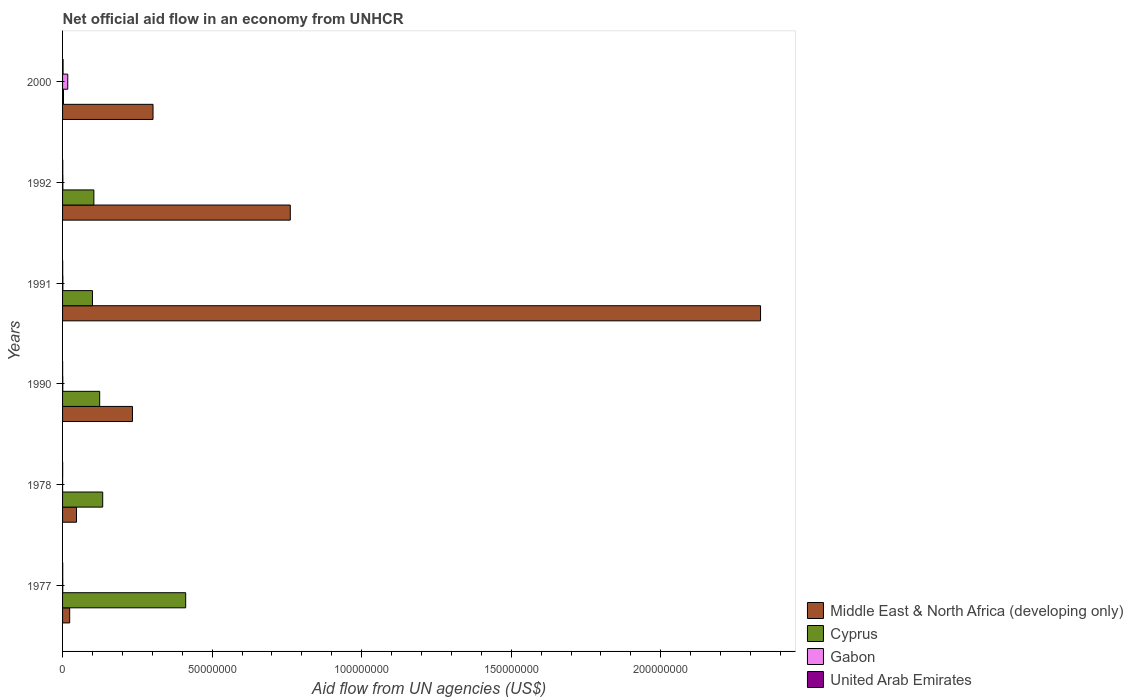How many different coloured bars are there?
Your answer should be very brief. 4. How many groups of bars are there?
Offer a very short reply. 6. Are the number of bars on each tick of the Y-axis equal?
Your answer should be very brief. Yes. How many bars are there on the 6th tick from the top?
Offer a very short reply. 4. How many bars are there on the 2nd tick from the bottom?
Your answer should be compact. 4. In how many cases, is the number of bars for a given year not equal to the number of legend labels?
Give a very brief answer. 0. Across all years, what is the maximum net official aid flow in Middle East & North Africa (developing only)?
Your response must be concise. 2.33e+08. In which year was the net official aid flow in Cyprus maximum?
Ensure brevity in your answer.  1977. In which year was the net official aid flow in Middle East & North Africa (developing only) minimum?
Ensure brevity in your answer.  1977. What is the total net official aid flow in Cyprus in the graph?
Your answer should be very brief. 8.78e+07. What is the difference between the net official aid flow in Cyprus in 1977 and that in 1992?
Give a very brief answer. 3.07e+07. What is the difference between the net official aid flow in United Arab Emirates in 1990 and the net official aid flow in Cyprus in 1978?
Your response must be concise. -1.34e+07. What is the average net official aid flow in Cyprus per year?
Your answer should be very brief. 1.46e+07. In the year 1990, what is the difference between the net official aid flow in Cyprus and net official aid flow in Gabon?
Make the answer very short. 1.23e+07. Is the difference between the net official aid flow in Cyprus in 1991 and 2000 greater than the difference between the net official aid flow in Gabon in 1991 and 2000?
Provide a succinct answer. Yes. What is the difference between the highest and the second highest net official aid flow in Gabon?
Offer a very short reply. 1.64e+06. What is the difference between the highest and the lowest net official aid flow in Gabon?
Ensure brevity in your answer.  1.73e+06. Is it the case that in every year, the sum of the net official aid flow in Middle East & North Africa (developing only) and net official aid flow in Cyprus is greater than the sum of net official aid flow in Gabon and net official aid flow in United Arab Emirates?
Ensure brevity in your answer.  Yes. What does the 3rd bar from the top in 1992 represents?
Your answer should be compact. Cyprus. What does the 4th bar from the bottom in 1990 represents?
Ensure brevity in your answer.  United Arab Emirates. Is it the case that in every year, the sum of the net official aid flow in Cyprus and net official aid flow in United Arab Emirates is greater than the net official aid flow in Middle East & North Africa (developing only)?
Give a very brief answer. No. How many bars are there?
Provide a short and direct response. 24. Are all the bars in the graph horizontal?
Provide a short and direct response. Yes. How many years are there in the graph?
Offer a terse response. 6. What is the difference between two consecutive major ticks on the X-axis?
Give a very brief answer. 5.00e+07. Does the graph contain any zero values?
Offer a very short reply. No. How many legend labels are there?
Your response must be concise. 4. How are the legend labels stacked?
Make the answer very short. Vertical. What is the title of the graph?
Your answer should be compact. Net official aid flow in an economy from UNHCR. Does "Philippines" appear as one of the legend labels in the graph?
Give a very brief answer. No. What is the label or title of the X-axis?
Provide a short and direct response. Aid flow from UN agencies (US$). What is the Aid flow from UN agencies (US$) of Middle East & North Africa (developing only) in 1977?
Make the answer very short. 2.38e+06. What is the Aid flow from UN agencies (US$) of Cyprus in 1977?
Make the answer very short. 4.12e+07. What is the Aid flow from UN agencies (US$) of Gabon in 1977?
Your answer should be compact. 6.00e+04. What is the Aid flow from UN agencies (US$) of United Arab Emirates in 1977?
Provide a short and direct response. 5.00e+04. What is the Aid flow from UN agencies (US$) of Middle East & North Africa (developing only) in 1978?
Your answer should be compact. 4.66e+06. What is the Aid flow from UN agencies (US$) of Cyprus in 1978?
Provide a short and direct response. 1.34e+07. What is the Aid flow from UN agencies (US$) of Gabon in 1978?
Ensure brevity in your answer.  10000. What is the Aid flow from UN agencies (US$) in Middle East & North Africa (developing only) in 1990?
Your answer should be compact. 2.34e+07. What is the Aid flow from UN agencies (US$) of Cyprus in 1990?
Offer a terse response. 1.24e+07. What is the Aid flow from UN agencies (US$) in Gabon in 1990?
Your answer should be very brief. 7.00e+04. What is the Aid flow from UN agencies (US$) of United Arab Emirates in 1990?
Your answer should be very brief. 2.00e+04. What is the Aid flow from UN agencies (US$) in Middle East & North Africa (developing only) in 1991?
Your response must be concise. 2.33e+08. What is the Aid flow from UN agencies (US$) of Cyprus in 1991?
Offer a very short reply. 1.00e+07. What is the Aid flow from UN agencies (US$) in Gabon in 1991?
Your response must be concise. 1.00e+05. What is the Aid flow from UN agencies (US$) in Middle East & North Africa (developing only) in 1992?
Your answer should be compact. 7.61e+07. What is the Aid flow from UN agencies (US$) of Cyprus in 1992?
Give a very brief answer. 1.05e+07. What is the Aid flow from UN agencies (US$) of Gabon in 1992?
Your response must be concise. 1.00e+05. What is the Aid flow from UN agencies (US$) in Middle East & North Africa (developing only) in 2000?
Keep it short and to the point. 3.02e+07. What is the Aid flow from UN agencies (US$) of Cyprus in 2000?
Offer a terse response. 3.10e+05. What is the Aid flow from UN agencies (US$) in Gabon in 2000?
Your answer should be very brief. 1.74e+06. Across all years, what is the maximum Aid flow from UN agencies (US$) in Middle East & North Africa (developing only)?
Your answer should be compact. 2.33e+08. Across all years, what is the maximum Aid flow from UN agencies (US$) in Cyprus?
Give a very brief answer. 4.12e+07. Across all years, what is the maximum Aid flow from UN agencies (US$) in Gabon?
Ensure brevity in your answer.  1.74e+06. Across all years, what is the minimum Aid flow from UN agencies (US$) of Middle East & North Africa (developing only)?
Give a very brief answer. 2.38e+06. Across all years, what is the minimum Aid flow from UN agencies (US$) in United Arab Emirates?
Provide a short and direct response. 2.00e+04. What is the total Aid flow from UN agencies (US$) of Middle East & North Africa (developing only) in the graph?
Your response must be concise. 3.70e+08. What is the total Aid flow from UN agencies (US$) of Cyprus in the graph?
Make the answer very short. 8.78e+07. What is the total Aid flow from UN agencies (US$) in Gabon in the graph?
Your answer should be very brief. 2.08e+06. What is the total Aid flow from UN agencies (US$) in United Arab Emirates in the graph?
Your answer should be very brief. 3.70e+05. What is the difference between the Aid flow from UN agencies (US$) of Middle East & North Africa (developing only) in 1977 and that in 1978?
Provide a short and direct response. -2.28e+06. What is the difference between the Aid flow from UN agencies (US$) in Cyprus in 1977 and that in 1978?
Provide a short and direct response. 2.78e+07. What is the difference between the Aid flow from UN agencies (US$) in Gabon in 1977 and that in 1978?
Offer a terse response. 5.00e+04. What is the difference between the Aid flow from UN agencies (US$) in Middle East & North Africa (developing only) in 1977 and that in 1990?
Offer a terse response. -2.10e+07. What is the difference between the Aid flow from UN agencies (US$) of Cyprus in 1977 and that in 1990?
Keep it short and to the point. 2.88e+07. What is the difference between the Aid flow from UN agencies (US$) in Middle East & North Africa (developing only) in 1977 and that in 1991?
Offer a terse response. -2.31e+08. What is the difference between the Aid flow from UN agencies (US$) in Cyprus in 1977 and that in 1991?
Ensure brevity in your answer.  3.12e+07. What is the difference between the Aid flow from UN agencies (US$) in United Arab Emirates in 1977 and that in 1991?
Give a very brief answer. 10000. What is the difference between the Aid flow from UN agencies (US$) in Middle East & North Africa (developing only) in 1977 and that in 1992?
Your response must be concise. -7.38e+07. What is the difference between the Aid flow from UN agencies (US$) in Cyprus in 1977 and that in 1992?
Ensure brevity in your answer.  3.07e+07. What is the difference between the Aid flow from UN agencies (US$) in Middle East & North Africa (developing only) in 1977 and that in 2000?
Provide a short and direct response. -2.79e+07. What is the difference between the Aid flow from UN agencies (US$) in Cyprus in 1977 and that in 2000?
Give a very brief answer. 4.09e+07. What is the difference between the Aid flow from UN agencies (US$) of Gabon in 1977 and that in 2000?
Provide a short and direct response. -1.68e+06. What is the difference between the Aid flow from UN agencies (US$) of Middle East & North Africa (developing only) in 1978 and that in 1990?
Ensure brevity in your answer.  -1.87e+07. What is the difference between the Aid flow from UN agencies (US$) of Cyprus in 1978 and that in 1990?
Your answer should be very brief. 1.01e+06. What is the difference between the Aid flow from UN agencies (US$) in Middle East & North Africa (developing only) in 1978 and that in 1991?
Ensure brevity in your answer.  -2.29e+08. What is the difference between the Aid flow from UN agencies (US$) in Cyprus in 1978 and that in 1991?
Ensure brevity in your answer.  3.42e+06. What is the difference between the Aid flow from UN agencies (US$) of Middle East & North Africa (developing only) in 1978 and that in 1992?
Ensure brevity in your answer.  -7.15e+07. What is the difference between the Aid flow from UN agencies (US$) of Cyprus in 1978 and that in 1992?
Provide a short and direct response. 2.95e+06. What is the difference between the Aid flow from UN agencies (US$) of Gabon in 1978 and that in 1992?
Your answer should be very brief. -9.00e+04. What is the difference between the Aid flow from UN agencies (US$) in United Arab Emirates in 1978 and that in 1992?
Keep it short and to the point. -3.00e+04. What is the difference between the Aid flow from UN agencies (US$) in Middle East & North Africa (developing only) in 1978 and that in 2000?
Keep it short and to the point. -2.56e+07. What is the difference between the Aid flow from UN agencies (US$) in Cyprus in 1978 and that in 2000?
Provide a succinct answer. 1.31e+07. What is the difference between the Aid flow from UN agencies (US$) in Gabon in 1978 and that in 2000?
Offer a very short reply. -1.73e+06. What is the difference between the Aid flow from UN agencies (US$) in Middle East & North Africa (developing only) in 1990 and that in 1991?
Your response must be concise. -2.10e+08. What is the difference between the Aid flow from UN agencies (US$) of Cyprus in 1990 and that in 1991?
Your response must be concise. 2.41e+06. What is the difference between the Aid flow from UN agencies (US$) in Gabon in 1990 and that in 1991?
Make the answer very short. -3.00e+04. What is the difference between the Aid flow from UN agencies (US$) in United Arab Emirates in 1990 and that in 1991?
Provide a short and direct response. -2.00e+04. What is the difference between the Aid flow from UN agencies (US$) in Middle East & North Africa (developing only) in 1990 and that in 1992?
Provide a succinct answer. -5.28e+07. What is the difference between the Aid flow from UN agencies (US$) in Cyprus in 1990 and that in 1992?
Ensure brevity in your answer.  1.94e+06. What is the difference between the Aid flow from UN agencies (US$) in United Arab Emirates in 1990 and that in 1992?
Ensure brevity in your answer.  -4.00e+04. What is the difference between the Aid flow from UN agencies (US$) in Middle East & North Africa (developing only) in 1990 and that in 2000?
Ensure brevity in your answer.  -6.88e+06. What is the difference between the Aid flow from UN agencies (US$) of Cyprus in 1990 and that in 2000?
Keep it short and to the point. 1.21e+07. What is the difference between the Aid flow from UN agencies (US$) in Gabon in 1990 and that in 2000?
Your response must be concise. -1.67e+06. What is the difference between the Aid flow from UN agencies (US$) of United Arab Emirates in 1990 and that in 2000?
Ensure brevity in your answer.  -1.50e+05. What is the difference between the Aid flow from UN agencies (US$) in Middle East & North Africa (developing only) in 1991 and that in 1992?
Give a very brief answer. 1.57e+08. What is the difference between the Aid flow from UN agencies (US$) of Cyprus in 1991 and that in 1992?
Keep it short and to the point. -4.70e+05. What is the difference between the Aid flow from UN agencies (US$) of United Arab Emirates in 1991 and that in 1992?
Give a very brief answer. -2.00e+04. What is the difference between the Aid flow from UN agencies (US$) of Middle East & North Africa (developing only) in 1991 and that in 2000?
Your answer should be compact. 2.03e+08. What is the difference between the Aid flow from UN agencies (US$) in Cyprus in 1991 and that in 2000?
Your answer should be very brief. 9.69e+06. What is the difference between the Aid flow from UN agencies (US$) in Gabon in 1991 and that in 2000?
Offer a very short reply. -1.64e+06. What is the difference between the Aid flow from UN agencies (US$) in Middle East & North Africa (developing only) in 1992 and that in 2000?
Give a very brief answer. 4.59e+07. What is the difference between the Aid flow from UN agencies (US$) in Cyprus in 1992 and that in 2000?
Keep it short and to the point. 1.02e+07. What is the difference between the Aid flow from UN agencies (US$) in Gabon in 1992 and that in 2000?
Your answer should be very brief. -1.64e+06. What is the difference between the Aid flow from UN agencies (US$) of United Arab Emirates in 1992 and that in 2000?
Your answer should be very brief. -1.10e+05. What is the difference between the Aid flow from UN agencies (US$) in Middle East & North Africa (developing only) in 1977 and the Aid flow from UN agencies (US$) in Cyprus in 1978?
Your answer should be compact. -1.10e+07. What is the difference between the Aid flow from UN agencies (US$) in Middle East & North Africa (developing only) in 1977 and the Aid flow from UN agencies (US$) in Gabon in 1978?
Keep it short and to the point. 2.37e+06. What is the difference between the Aid flow from UN agencies (US$) of Middle East & North Africa (developing only) in 1977 and the Aid flow from UN agencies (US$) of United Arab Emirates in 1978?
Make the answer very short. 2.35e+06. What is the difference between the Aid flow from UN agencies (US$) in Cyprus in 1977 and the Aid flow from UN agencies (US$) in Gabon in 1978?
Your answer should be very brief. 4.12e+07. What is the difference between the Aid flow from UN agencies (US$) of Cyprus in 1977 and the Aid flow from UN agencies (US$) of United Arab Emirates in 1978?
Offer a very short reply. 4.11e+07. What is the difference between the Aid flow from UN agencies (US$) of Middle East & North Africa (developing only) in 1977 and the Aid flow from UN agencies (US$) of Cyprus in 1990?
Offer a terse response. -1.00e+07. What is the difference between the Aid flow from UN agencies (US$) in Middle East & North Africa (developing only) in 1977 and the Aid flow from UN agencies (US$) in Gabon in 1990?
Ensure brevity in your answer.  2.31e+06. What is the difference between the Aid flow from UN agencies (US$) in Middle East & North Africa (developing only) in 1977 and the Aid flow from UN agencies (US$) in United Arab Emirates in 1990?
Offer a terse response. 2.36e+06. What is the difference between the Aid flow from UN agencies (US$) in Cyprus in 1977 and the Aid flow from UN agencies (US$) in Gabon in 1990?
Your answer should be compact. 4.11e+07. What is the difference between the Aid flow from UN agencies (US$) in Cyprus in 1977 and the Aid flow from UN agencies (US$) in United Arab Emirates in 1990?
Your answer should be compact. 4.12e+07. What is the difference between the Aid flow from UN agencies (US$) of Gabon in 1977 and the Aid flow from UN agencies (US$) of United Arab Emirates in 1990?
Ensure brevity in your answer.  4.00e+04. What is the difference between the Aid flow from UN agencies (US$) in Middle East & North Africa (developing only) in 1977 and the Aid flow from UN agencies (US$) in Cyprus in 1991?
Offer a very short reply. -7.62e+06. What is the difference between the Aid flow from UN agencies (US$) in Middle East & North Africa (developing only) in 1977 and the Aid flow from UN agencies (US$) in Gabon in 1991?
Your answer should be very brief. 2.28e+06. What is the difference between the Aid flow from UN agencies (US$) in Middle East & North Africa (developing only) in 1977 and the Aid flow from UN agencies (US$) in United Arab Emirates in 1991?
Provide a short and direct response. 2.34e+06. What is the difference between the Aid flow from UN agencies (US$) in Cyprus in 1977 and the Aid flow from UN agencies (US$) in Gabon in 1991?
Keep it short and to the point. 4.11e+07. What is the difference between the Aid flow from UN agencies (US$) in Cyprus in 1977 and the Aid flow from UN agencies (US$) in United Arab Emirates in 1991?
Offer a terse response. 4.11e+07. What is the difference between the Aid flow from UN agencies (US$) of Middle East & North Africa (developing only) in 1977 and the Aid flow from UN agencies (US$) of Cyprus in 1992?
Keep it short and to the point. -8.09e+06. What is the difference between the Aid flow from UN agencies (US$) of Middle East & North Africa (developing only) in 1977 and the Aid flow from UN agencies (US$) of Gabon in 1992?
Ensure brevity in your answer.  2.28e+06. What is the difference between the Aid flow from UN agencies (US$) in Middle East & North Africa (developing only) in 1977 and the Aid flow from UN agencies (US$) in United Arab Emirates in 1992?
Provide a short and direct response. 2.32e+06. What is the difference between the Aid flow from UN agencies (US$) in Cyprus in 1977 and the Aid flow from UN agencies (US$) in Gabon in 1992?
Your answer should be compact. 4.11e+07. What is the difference between the Aid flow from UN agencies (US$) of Cyprus in 1977 and the Aid flow from UN agencies (US$) of United Arab Emirates in 1992?
Offer a terse response. 4.11e+07. What is the difference between the Aid flow from UN agencies (US$) in Middle East & North Africa (developing only) in 1977 and the Aid flow from UN agencies (US$) in Cyprus in 2000?
Make the answer very short. 2.07e+06. What is the difference between the Aid flow from UN agencies (US$) in Middle East & North Africa (developing only) in 1977 and the Aid flow from UN agencies (US$) in Gabon in 2000?
Offer a very short reply. 6.40e+05. What is the difference between the Aid flow from UN agencies (US$) in Middle East & North Africa (developing only) in 1977 and the Aid flow from UN agencies (US$) in United Arab Emirates in 2000?
Your answer should be very brief. 2.21e+06. What is the difference between the Aid flow from UN agencies (US$) of Cyprus in 1977 and the Aid flow from UN agencies (US$) of Gabon in 2000?
Your response must be concise. 3.94e+07. What is the difference between the Aid flow from UN agencies (US$) in Cyprus in 1977 and the Aid flow from UN agencies (US$) in United Arab Emirates in 2000?
Give a very brief answer. 4.10e+07. What is the difference between the Aid flow from UN agencies (US$) of Gabon in 1977 and the Aid flow from UN agencies (US$) of United Arab Emirates in 2000?
Offer a very short reply. -1.10e+05. What is the difference between the Aid flow from UN agencies (US$) in Middle East & North Africa (developing only) in 1978 and the Aid flow from UN agencies (US$) in Cyprus in 1990?
Provide a short and direct response. -7.75e+06. What is the difference between the Aid flow from UN agencies (US$) in Middle East & North Africa (developing only) in 1978 and the Aid flow from UN agencies (US$) in Gabon in 1990?
Offer a very short reply. 4.59e+06. What is the difference between the Aid flow from UN agencies (US$) of Middle East & North Africa (developing only) in 1978 and the Aid flow from UN agencies (US$) of United Arab Emirates in 1990?
Your answer should be compact. 4.64e+06. What is the difference between the Aid flow from UN agencies (US$) in Cyprus in 1978 and the Aid flow from UN agencies (US$) in Gabon in 1990?
Provide a succinct answer. 1.34e+07. What is the difference between the Aid flow from UN agencies (US$) in Cyprus in 1978 and the Aid flow from UN agencies (US$) in United Arab Emirates in 1990?
Provide a succinct answer. 1.34e+07. What is the difference between the Aid flow from UN agencies (US$) of Gabon in 1978 and the Aid flow from UN agencies (US$) of United Arab Emirates in 1990?
Your answer should be compact. -10000. What is the difference between the Aid flow from UN agencies (US$) of Middle East & North Africa (developing only) in 1978 and the Aid flow from UN agencies (US$) of Cyprus in 1991?
Keep it short and to the point. -5.34e+06. What is the difference between the Aid flow from UN agencies (US$) of Middle East & North Africa (developing only) in 1978 and the Aid flow from UN agencies (US$) of Gabon in 1991?
Ensure brevity in your answer.  4.56e+06. What is the difference between the Aid flow from UN agencies (US$) of Middle East & North Africa (developing only) in 1978 and the Aid flow from UN agencies (US$) of United Arab Emirates in 1991?
Provide a succinct answer. 4.62e+06. What is the difference between the Aid flow from UN agencies (US$) in Cyprus in 1978 and the Aid flow from UN agencies (US$) in Gabon in 1991?
Your response must be concise. 1.33e+07. What is the difference between the Aid flow from UN agencies (US$) of Cyprus in 1978 and the Aid flow from UN agencies (US$) of United Arab Emirates in 1991?
Offer a terse response. 1.34e+07. What is the difference between the Aid flow from UN agencies (US$) of Gabon in 1978 and the Aid flow from UN agencies (US$) of United Arab Emirates in 1991?
Keep it short and to the point. -3.00e+04. What is the difference between the Aid flow from UN agencies (US$) in Middle East & North Africa (developing only) in 1978 and the Aid flow from UN agencies (US$) in Cyprus in 1992?
Make the answer very short. -5.81e+06. What is the difference between the Aid flow from UN agencies (US$) in Middle East & North Africa (developing only) in 1978 and the Aid flow from UN agencies (US$) in Gabon in 1992?
Your answer should be very brief. 4.56e+06. What is the difference between the Aid flow from UN agencies (US$) of Middle East & North Africa (developing only) in 1978 and the Aid flow from UN agencies (US$) of United Arab Emirates in 1992?
Keep it short and to the point. 4.60e+06. What is the difference between the Aid flow from UN agencies (US$) in Cyprus in 1978 and the Aid flow from UN agencies (US$) in Gabon in 1992?
Your response must be concise. 1.33e+07. What is the difference between the Aid flow from UN agencies (US$) in Cyprus in 1978 and the Aid flow from UN agencies (US$) in United Arab Emirates in 1992?
Give a very brief answer. 1.34e+07. What is the difference between the Aid flow from UN agencies (US$) of Middle East & North Africa (developing only) in 1978 and the Aid flow from UN agencies (US$) of Cyprus in 2000?
Ensure brevity in your answer.  4.35e+06. What is the difference between the Aid flow from UN agencies (US$) of Middle East & North Africa (developing only) in 1978 and the Aid flow from UN agencies (US$) of Gabon in 2000?
Offer a very short reply. 2.92e+06. What is the difference between the Aid flow from UN agencies (US$) in Middle East & North Africa (developing only) in 1978 and the Aid flow from UN agencies (US$) in United Arab Emirates in 2000?
Give a very brief answer. 4.49e+06. What is the difference between the Aid flow from UN agencies (US$) in Cyprus in 1978 and the Aid flow from UN agencies (US$) in Gabon in 2000?
Give a very brief answer. 1.17e+07. What is the difference between the Aid flow from UN agencies (US$) in Cyprus in 1978 and the Aid flow from UN agencies (US$) in United Arab Emirates in 2000?
Make the answer very short. 1.32e+07. What is the difference between the Aid flow from UN agencies (US$) in Gabon in 1978 and the Aid flow from UN agencies (US$) in United Arab Emirates in 2000?
Your response must be concise. -1.60e+05. What is the difference between the Aid flow from UN agencies (US$) of Middle East & North Africa (developing only) in 1990 and the Aid flow from UN agencies (US$) of Cyprus in 1991?
Your response must be concise. 1.34e+07. What is the difference between the Aid flow from UN agencies (US$) in Middle East & North Africa (developing only) in 1990 and the Aid flow from UN agencies (US$) in Gabon in 1991?
Give a very brief answer. 2.33e+07. What is the difference between the Aid flow from UN agencies (US$) in Middle East & North Africa (developing only) in 1990 and the Aid flow from UN agencies (US$) in United Arab Emirates in 1991?
Make the answer very short. 2.33e+07. What is the difference between the Aid flow from UN agencies (US$) in Cyprus in 1990 and the Aid flow from UN agencies (US$) in Gabon in 1991?
Offer a terse response. 1.23e+07. What is the difference between the Aid flow from UN agencies (US$) in Cyprus in 1990 and the Aid flow from UN agencies (US$) in United Arab Emirates in 1991?
Your answer should be compact. 1.24e+07. What is the difference between the Aid flow from UN agencies (US$) in Middle East & North Africa (developing only) in 1990 and the Aid flow from UN agencies (US$) in Cyprus in 1992?
Keep it short and to the point. 1.29e+07. What is the difference between the Aid flow from UN agencies (US$) in Middle East & North Africa (developing only) in 1990 and the Aid flow from UN agencies (US$) in Gabon in 1992?
Offer a very short reply. 2.33e+07. What is the difference between the Aid flow from UN agencies (US$) of Middle East & North Africa (developing only) in 1990 and the Aid flow from UN agencies (US$) of United Arab Emirates in 1992?
Your answer should be compact. 2.33e+07. What is the difference between the Aid flow from UN agencies (US$) of Cyprus in 1990 and the Aid flow from UN agencies (US$) of Gabon in 1992?
Give a very brief answer. 1.23e+07. What is the difference between the Aid flow from UN agencies (US$) of Cyprus in 1990 and the Aid flow from UN agencies (US$) of United Arab Emirates in 1992?
Your answer should be compact. 1.24e+07. What is the difference between the Aid flow from UN agencies (US$) of Middle East & North Africa (developing only) in 1990 and the Aid flow from UN agencies (US$) of Cyprus in 2000?
Offer a very short reply. 2.31e+07. What is the difference between the Aid flow from UN agencies (US$) of Middle East & North Africa (developing only) in 1990 and the Aid flow from UN agencies (US$) of Gabon in 2000?
Provide a succinct answer. 2.16e+07. What is the difference between the Aid flow from UN agencies (US$) in Middle East & North Africa (developing only) in 1990 and the Aid flow from UN agencies (US$) in United Arab Emirates in 2000?
Your answer should be very brief. 2.32e+07. What is the difference between the Aid flow from UN agencies (US$) in Cyprus in 1990 and the Aid flow from UN agencies (US$) in Gabon in 2000?
Provide a short and direct response. 1.07e+07. What is the difference between the Aid flow from UN agencies (US$) of Cyprus in 1990 and the Aid flow from UN agencies (US$) of United Arab Emirates in 2000?
Provide a short and direct response. 1.22e+07. What is the difference between the Aid flow from UN agencies (US$) of Middle East & North Africa (developing only) in 1991 and the Aid flow from UN agencies (US$) of Cyprus in 1992?
Make the answer very short. 2.23e+08. What is the difference between the Aid flow from UN agencies (US$) in Middle East & North Africa (developing only) in 1991 and the Aid flow from UN agencies (US$) in Gabon in 1992?
Provide a succinct answer. 2.33e+08. What is the difference between the Aid flow from UN agencies (US$) in Middle East & North Africa (developing only) in 1991 and the Aid flow from UN agencies (US$) in United Arab Emirates in 1992?
Give a very brief answer. 2.33e+08. What is the difference between the Aid flow from UN agencies (US$) of Cyprus in 1991 and the Aid flow from UN agencies (US$) of Gabon in 1992?
Provide a short and direct response. 9.90e+06. What is the difference between the Aid flow from UN agencies (US$) of Cyprus in 1991 and the Aid flow from UN agencies (US$) of United Arab Emirates in 1992?
Give a very brief answer. 9.94e+06. What is the difference between the Aid flow from UN agencies (US$) of Gabon in 1991 and the Aid flow from UN agencies (US$) of United Arab Emirates in 1992?
Your response must be concise. 4.00e+04. What is the difference between the Aid flow from UN agencies (US$) in Middle East & North Africa (developing only) in 1991 and the Aid flow from UN agencies (US$) in Cyprus in 2000?
Keep it short and to the point. 2.33e+08. What is the difference between the Aid flow from UN agencies (US$) in Middle East & North Africa (developing only) in 1991 and the Aid flow from UN agencies (US$) in Gabon in 2000?
Your answer should be very brief. 2.32e+08. What is the difference between the Aid flow from UN agencies (US$) in Middle East & North Africa (developing only) in 1991 and the Aid flow from UN agencies (US$) in United Arab Emirates in 2000?
Offer a terse response. 2.33e+08. What is the difference between the Aid flow from UN agencies (US$) in Cyprus in 1991 and the Aid flow from UN agencies (US$) in Gabon in 2000?
Provide a succinct answer. 8.26e+06. What is the difference between the Aid flow from UN agencies (US$) in Cyprus in 1991 and the Aid flow from UN agencies (US$) in United Arab Emirates in 2000?
Your response must be concise. 9.83e+06. What is the difference between the Aid flow from UN agencies (US$) of Gabon in 1991 and the Aid flow from UN agencies (US$) of United Arab Emirates in 2000?
Keep it short and to the point. -7.00e+04. What is the difference between the Aid flow from UN agencies (US$) of Middle East & North Africa (developing only) in 1992 and the Aid flow from UN agencies (US$) of Cyprus in 2000?
Provide a succinct answer. 7.58e+07. What is the difference between the Aid flow from UN agencies (US$) in Middle East & North Africa (developing only) in 1992 and the Aid flow from UN agencies (US$) in Gabon in 2000?
Keep it short and to the point. 7.44e+07. What is the difference between the Aid flow from UN agencies (US$) of Middle East & North Africa (developing only) in 1992 and the Aid flow from UN agencies (US$) of United Arab Emirates in 2000?
Offer a very short reply. 7.60e+07. What is the difference between the Aid flow from UN agencies (US$) in Cyprus in 1992 and the Aid flow from UN agencies (US$) in Gabon in 2000?
Ensure brevity in your answer.  8.73e+06. What is the difference between the Aid flow from UN agencies (US$) of Cyprus in 1992 and the Aid flow from UN agencies (US$) of United Arab Emirates in 2000?
Ensure brevity in your answer.  1.03e+07. What is the average Aid flow from UN agencies (US$) of Middle East & North Africa (developing only) per year?
Make the answer very short. 6.17e+07. What is the average Aid flow from UN agencies (US$) of Cyprus per year?
Provide a succinct answer. 1.46e+07. What is the average Aid flow from UN agencies (US$) in Gabon per year?
Your answer should be compact. 3.47e+05. What is the average Aid flow from UN agencies (US$) in United Arab Emirates per year?
Your response must be concise. 6.17e+04. In the year 1977, what is the difference between the Aid flow from UN agencies (US$) in Middle East & North Africa (developing only) and Aid flow from UN agencies (US$) in Cyprus?
Keep it short and to the point. -3.88e+07. In the year 1977, what is the difference between the Aid flow from UN agencies (US$) in Middle East & North Africa (developing only) and Aid flow from UN agencies (US$) in Gabon?
Offer a terse response. 2.32e+06. In the year 1977, what is the difference between the Aid flow from UN agencies (US$) of Middle East & North Africa (developing only) and Aid flow from UN agencies (US$) of United Arab Emirates?
Offer a very short reply. 2.33e+06. In the year 1977, what is the difference between the Aid flow from UN agencies (US$) in Cyprus and Aid flow from UN agencies (US$) in Gabon?
Offer a very short reply. 4.11e+07. In the year 1977, what is the difference between the Aid flow from UN agencies (US$) of Cyprus and Aid flow from UN agencies (US$) of United Arab Emirates?
Offer a terse response. 4.11e+07. In the year 1978, what is the difference between the Aid flow from UN agencies (US$) of Middle East & North Africa (developing only) and Aid flow from UN agencies (US$) of Cyprus?
Your answer should be compact. -8.76e+06. In the year 1978, what is the difference between the Aid flow from UN agencies (US$) in Middle East & North Africa (developing only) and Aid flow from UN agencies (US$) in Gabon?
Your answer should be very brief. 4.65e+06. In the year 1978, what is the difference between the Aid flow from UN agencies (US$) of Middle East & North Africa (developing only) and Aid flow from UN agencies (US$) of United Arab Emirates?
Your answer should be compact. 4.63e+06. In the year 1978, what is the difference between the Aid flow from UN agencies (US$) of Cyprus and Aid flow from UN agencies (US$) of Gabon?
Keep it short and to the point. 1.34e+07. In the year 1978, what is the difference between the Aid flow from UN agencies (US$) in Cyprus and Aid flow from UN agencies (US$) in United Arab Emirates?
Keep it short and to the point. 1.34e+07. In the year 1978, what is the difference between the Aid flow from UN agencies (US$) of Gabon and Aid flow from UN agencies (US$) of United Arab Emirates?
Give a very brief answer. -2.00e+04. In the year 1990, what is the difference between the Aid flow from UN agencies (US$) in Middle East & North Africa (developing only) and Aid flow from UN agencies (US$) in Cyprus?
Ensure brevity in your answer.  1.10e+07. In the year 1990, what is the difference between the Aid flow from UN agencies (US$) in Middle East & North Africa (developing only) and Aid flow from UN agencies (US$) in Gabon?
Offer a terse response. 2.33e+07. In the year 1990, what is the difference between the Aid flow from UN agencies (US$) in Middle East & North Africa (developing only) and Aid flow from UN agencies (US$) in United Arab Emirates?
Offer a very short reply. 2.34e+07. In the year 1990, what is the difference between the Aid flow from UN agencies (US$) of Cyprus and Aid flow from UN agencies (US$) of Gabon?
Your answer should be compact. 1.23e+07. In the year 1990, what is the difference between the Aid flow from UN agencies (US$) in Cyprus and Aid flow from UN agencies (US$) in United Arab Emirates?
Make the answer very short. 1.24e+07. In the year 1991, what is the difference between the Aid flow from UN agencies (US$) of Middle East & North Africa (developing only) and Aid flow from UN agencies (US$) of Cyprus?
Offer a very short reply. 2.23e+08. In the year 1991, what is the difference between the Aid flow from UN agencies (US$) of Middle East & North Africa (developing only) and Aid flow from UN agencies (US$) of Gabon?
Provide a succinct answer. 2.33e+08. In the year 1991, what is the difference between the Aid flow from UN agencies (US$) in Middle East & North Africa (developing only) and Aid flow from UN agencies (US$) in United Arab Emirates?
Your answer should be very brief. 2.33e+08. In the year 1991, what is the difference between the Aid flow from UN agencies (US$) of Cyprus and Aid flow from UN agencies (US$) of Gabon?
Keep it short and to the point. 9.90e+06. In the year 1991, what is the difference between the Aid flow from UN agencies (US$) in Cyprus and Aid flow from UN agencies (US$) in United Arab Emirates?
Provide a short and direct response. 9.96e+06. In the year 1992, what is the difference between the Aid flow from UN agencies (US$) of Middle East & North Africa (developing only) and Aid flow from UN agencies (US$) of Cyprus?
Give a very brief answer. 6.57e+07. In the year 1992, what is the difference between the Aid flow from UN agencies (US$) of Middle East & North Africa (developing only) and Aid flow from UN agencies (US$) of Gabon?
Your response must be concise. 7.60e+07. In the year 1992, what is the difference between the Aid flow from UN agencies (US$) in Middle East & North Africa (developing only) and Aid flow from UN agencies (US$) in United Arab Emirates?
Keep it short and to the point. 7.61e+07. In the year 1992, what is the difference between the Aid flow from UN agencies (US$) of Cyprus and Aid flow from UN agencies (US$) of Gabon?
Make the answer very short. 1.04e+07. In the year 1992, what is the difference between the Aid flow from UN agencies (US$) of Cyprus and Aid flow from UN agencies (US$) of United Arab Emirates?
Offer a terse response. 1.04e+07. In the year 1992, what is the difference between the Aid flow from UN agencies (US$) in Gabon and Aid flow from UN agencies (US$) in United Arab Emirates?
Provide a short and direct response. 4.00e+04. In the year 2000, what is the difference between the Aid flow from UN agencies (US$) of Middle East & North Africa (developing only) and Aid flow from UN agencies (US$) of Cyprus?
Your answer should be very brief. 2.99e+07. In the year 2000, what is the difference between the Aid flow from UN agencies (US$) of Middle East & North Africa (developing only) and Aid flow from UN agencies (US$) of Gabon?
Offer a very short reply. 2.85e+07. In the year 2000, what is the difference between the Aid flow from UN agencies (US$) in Middle East & North Africa (developing only) and Aid flow from UN agencies (US$) in United Arab Emirates?
Keep it short and to the point. 3.01e+07. In the year 2000, what is the difference between the Aid flow from UN agencies (US$) of Cyprus and Aid flow from UN agencies (US$) of Gabon?
Your response must be concise. -1.43e+06. In the year 2000, what is the difference between the Aid flow from UN agencies (US$) of Cyprus and Aid flow from UN agencies (US$) of United Arab Emirates?
Give a very brief answer. 1.40e+05. In the year 2000, what is the difference between the Aid flow from UN agencies (US$) of Gabon and Aid flow from UN agencies (US$) of United Arab Emirates?
Provide a succinct answer. 1.57e+06. What is the ratio of the Aid flow from UN agencies (US$) of Middle East & North Africa (developing only) in 1977 to that in 1978?
Your answer should be compact. 0.51. What is the ratio of the Aid flow from UN agencies (US$) of Cyprus in 1977 to that in 1978?
Your answer should be very brief. 3.07. What is the ratio of the Aid flow from UN agencies (US$) in Gabon in 1977 to that in 1978?
Your answer should be compact. 6. What is the ratio of the Aid flow from UN agencies (US$) in United Arab Emirates in 1977 to that in 1978?
Your answer should be very brief. 1.67. What is the ratio of the Aid flow from UN agencies (US$) of Middle East & North Africa (developing only) in 1977 to that in 1990?
Your answer should be very brief. 0.1. What is the ratio of the Aid flow from UN agencies (US$) of Cyprus in 1977 to that in 1990?
Your response must be concise. 3.32. What is the ratio of the Aid flow from UN agencies (US$) in United Arab Emirates in 1977 to that in 1990?
Ensure brevity in your answer.  2.5. What is the ratio of the Aid flow from UN agencies (US$) in Middle East & North Africa (developing only) in 1977 to that in 1991?
Offer a very short reply. 0.01. What is the ratio of the Aid flow from UN agencies (US$) of Cyprus in 1977 to that in 1991?
Offer a terse response. 4.12. What is the ratio of the Aid flow from UN agencies (US$) in Gabon in 1977 to that in 1991?
Offer a very short reply. 0.6. What is the ratio of the Aid flow from UN agencies (US$) in United Arab Emirates in 1977 to that in 1991?
Provide a succinct answer. 1.25. What is the ratio of the Aid flow from UN agencies (US$) in Middle East & North Africa (developing only) in 1977 to that in 1992?
Ensure brevity in your answer.  0.03. What is the ratio of the Aid flow from UN agencies (US$) of Cyprus in 1977 to that in 1992?
Ensure brevity in your answer.  3.93. What is the ratio of the Aid flow from UN agencies (US$) of Gabon in 1977 to that in 1992?
Offer a terse response. 0.6. What is the ratio of the Aid flow from UN agencies (US$) of United Arab Emirates in 1977 to that in 1992?
Give a very brief answer. 0.83. What is the ratio of the Aid flow from UN agencies (US$) of Middle East & North Africa (developing only) in 1977 to that in 2000?
Give a very brief answer. 0.08. What is the ratio of the Aid flow from UN agencies (US$) of Cyprus in 1977 to that in 2000?
Keep it short and to the point. 132.81. What is the ratio of the Aid flow from UN agencies (US$) in Gabon in 1977 to that in 2000?
Offer a terse response. 0.03. What is the ratio of the Aid flow from UN agencies (US$) in United Arab Emirates in 1977 to that in 2000?
Offer a very short reply. 0.29. What is the ratio of the Aid flow from UN agencies (US$) of Middle East & North Africa (developing only) in 1978 to that in 1990?
Provide a succinct answer. 0.2. What is the ratio of the Aid flow from UN agencies (US$) of Cyprus in 1978 to that in 1990?
Offer a very short reply. 1.08. What is the ratio of the Aid flow from UN agencies (US$) in Gabon in 1978 to that in 1990?
Your response must be concise. 0.14. What is the ratio of the Aid flow from UN agencies (US$) of Middle East & North Africa (developing only) in 1978 to that in 1991?
Your answer should be very brief. 0.02. What is the ratio of the Aid flow from UN agencies (US$) in Cyprus in 1978 to that in 1991?
Provide a short and direct response. 1.34. What is the ratio of the Aid flow from UN agencies (US$) of Middle East & North Africa (developing only) in 1978 to that in 1992?
Offer a terse response. 0.06. What is the ratio of the Aid flow from UN agencies (US$) in Cyprus in 1978 to that in 1992?
Offer a very short reply. 1.28. What is the ratio of the Aid flow from UN agencies (US$) in Gabon in 1978 to that in 1992?
Offer a terse response. 0.1. What is the ratio of the Aid flow from UN agencies (US$) in United Arab Emirates in 1978 to that in 1992?
Provide a succinct answer. 0.5. What is the ratio of the Aid flow from UN agencies (US$) in Middle East & North Africa (developing only) in 1978 to that in 2000?
Ensure brevity in your answer.  0.15. What is the ratio of the Aid flow from UN agencies (US$) in Cyprus in 1978 to that in 2000?
Keep it short and to the point. 43.29. What is the ratio of the Aid flow from UN agencies (US$) of Gabon in 1978 to that in 2000?
Make the answer very short. 0.01. What is the ratio of the Aid flow from UN agencies (US$) in United Arab Emirates in 1978 to that in 2000?
Give a very brief answer. 0.18. What is the ratio of the Aid flow from UN agencies (US$) of Middle East & North Africa (developing only) in 1990 to that in 1991?
Your answer should be compact. 0.1. What is the ratio of the Aid flow from UN agencies (US$) of Cyprus in 1990 to that in 1991?
Provide a short and direct response. 1.24. What is the ratio of the Aid flow from UN agencies (US$) of Gabon in 1990 to that in 1991?
Give a very brief answer. 0.7. What is the ratio of the Aid flow from UN agencies (US$) of United Arab Emirates in 1990 to that in 1991?
Your response must be concise. 0.5. What is the ratio of the Aid flow from UN agencies (US$) of Middle East & North Africa (developing only) in 1990 to that in 1992?
Offer a terse response. 0.31. What is the ratio of the Aid flow from UN agencies (US$) in Cyprus in 1990 to that in 1992?
Provide a succinct answer. 1.19. What is the ratio of the Aid flow from UN agencies (US$) in United Arab Emirates in 1990 to that in 1992?
Keep it short and to the point. 0.33. What is the ratio of the Aid flow from UN agencies (US$) of Middle East & North Africa (developing only) in 1990 to that in 2000?
Provide a succinct answer. 0.77. What is the ratio of the Aid flow from UN agencies (US$) in Cyprus in 1990 to that in 2000?
Provide a short and direct response. 40.03. What is the ratio of the Aid flow from UN agencies (US$) of Gabon in 1990 to that in 2000?
Keep it short and to the point. 0.04. What is the ratio of the Aid flow from UN agencies (US$) of United Arab Emirates in 1990 to that in 2000?
Your response must be concise. 0.12. What is the ratio of the Aid flow from UN agencies (US$) in Middle East & North Africa (developing only) in 1991 to that in 1992?
Provide a succinct answer. 3.07. What is the ratio of the Aid flow from UN agencies (US$) of Cyprus in 1991 to that in 1992?
Your answer should be compact. 0.96. What is the ratio of the Aid flow from UN agencies (US$) of Middle East & North Africa (developing only) in 1991 to that in 2000?
Offer a terse response. 7.71. What is the ratio of the Aid flow from UN agencies (US$) in Cyprus in 1991 to that in 2000?
Ensure brevity in your answer.  32.26. What is the ratio of the Aid flow from UN agencies (US$) of Gabon in 1991 to that in 2000?
Provide a short and direct response. 0.06. What is the ratio of the Aid flow from UN agencies (US$) of United Arab Emirates in 1991 to that in 2000?
Your answer should be very brief. 0.24. What is the ratio of the Aid flow from UN agencies (US$) in Middle East & North Africa (developing only) in 1992 to that in 2000?
Give a very brief answer. 2.52. What is the ratio of the Aid flow from UN agencies (US$) of Cyprus in 1992 to that in 2000?
Your answer should be very brief. 33.77. What is the ratio of the Aid flow from UN agencies (US$) of Gabon in 1992 to that in 2000?
Ensure brevity in your answer.  0.06. What is the ratio of the Aid flow from UN agencies (US$) of United Arab Emirates in 1992 to that in 2000?
Make the answer very short. 0.35. What is the difference between the highest and the second highest Aid flow from UN agencies (US$) of Middle East & North Africa (developing only)?
Offer a terse response. 1.57e+08. What is the difference between the highest and the second highest Aid flow from UN agencies (US$) of Cyprus?
Your response must be concise. 2.78e+07. What is the difference between the highest and the second highest Aid flow from UN agencies (US$) of Gabon?
Make the answer very short. 1.64e+06. What is the difference between the highest and the second highest Aid flow from UN agencies (US$) of United Arab Emirates?
Offer a very short reply. 1.10e+05. What is the difference between the highest and the lowest Aid flow from UN agencies (US$) in Middle East & North Africa (developing only)?
Your answer should be compact. 2.31e+08. What is the difference between the highest and the lowest Aid flow from UN agencies (US$) in Cyprus?
Ensure brevity in your answer.  4.09e+07. What is the difference between the highest and the lowest Aid flow from UN agencies (US$) in Gabon?
Provide a short and direct response. 1.73e+06. 